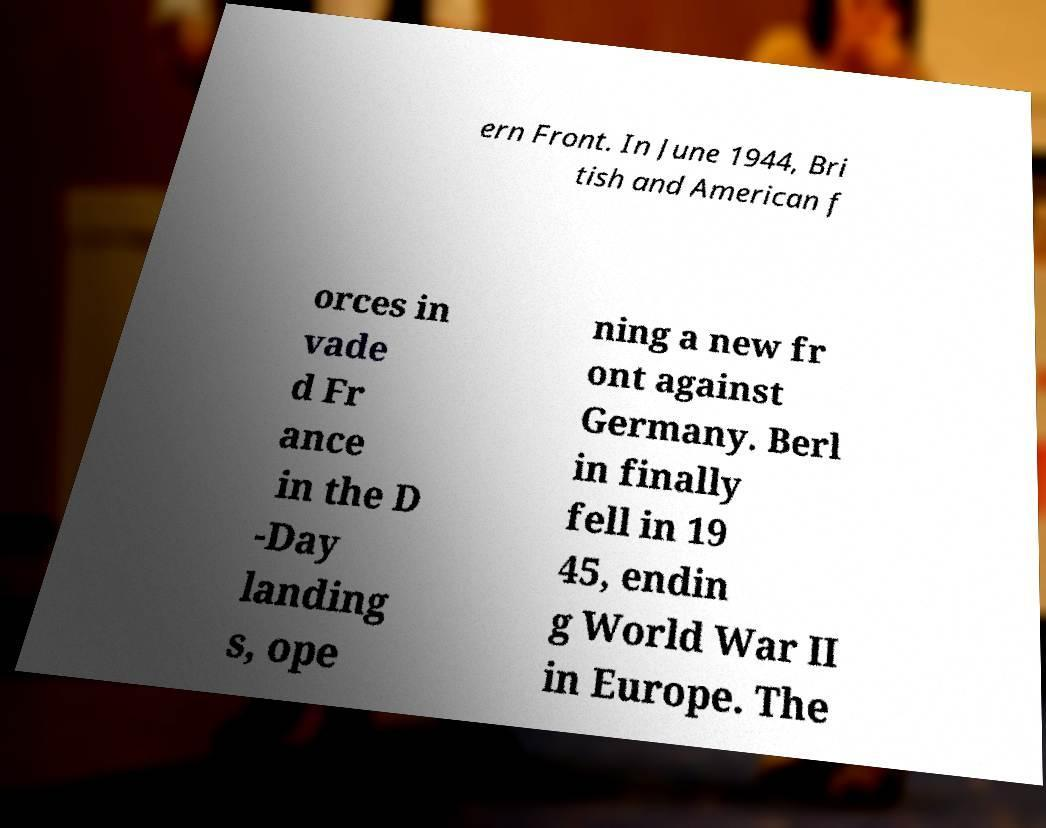I need the written content from this picture converted into text. Can you do that? ern Front. In June 1944, Bri tish and American f orces in vade d Fr ance in the D -Day landing s, ope ning a new fr ont against Germany. Berl in finally fell in 19 45, endin g World War II in Europe. The 